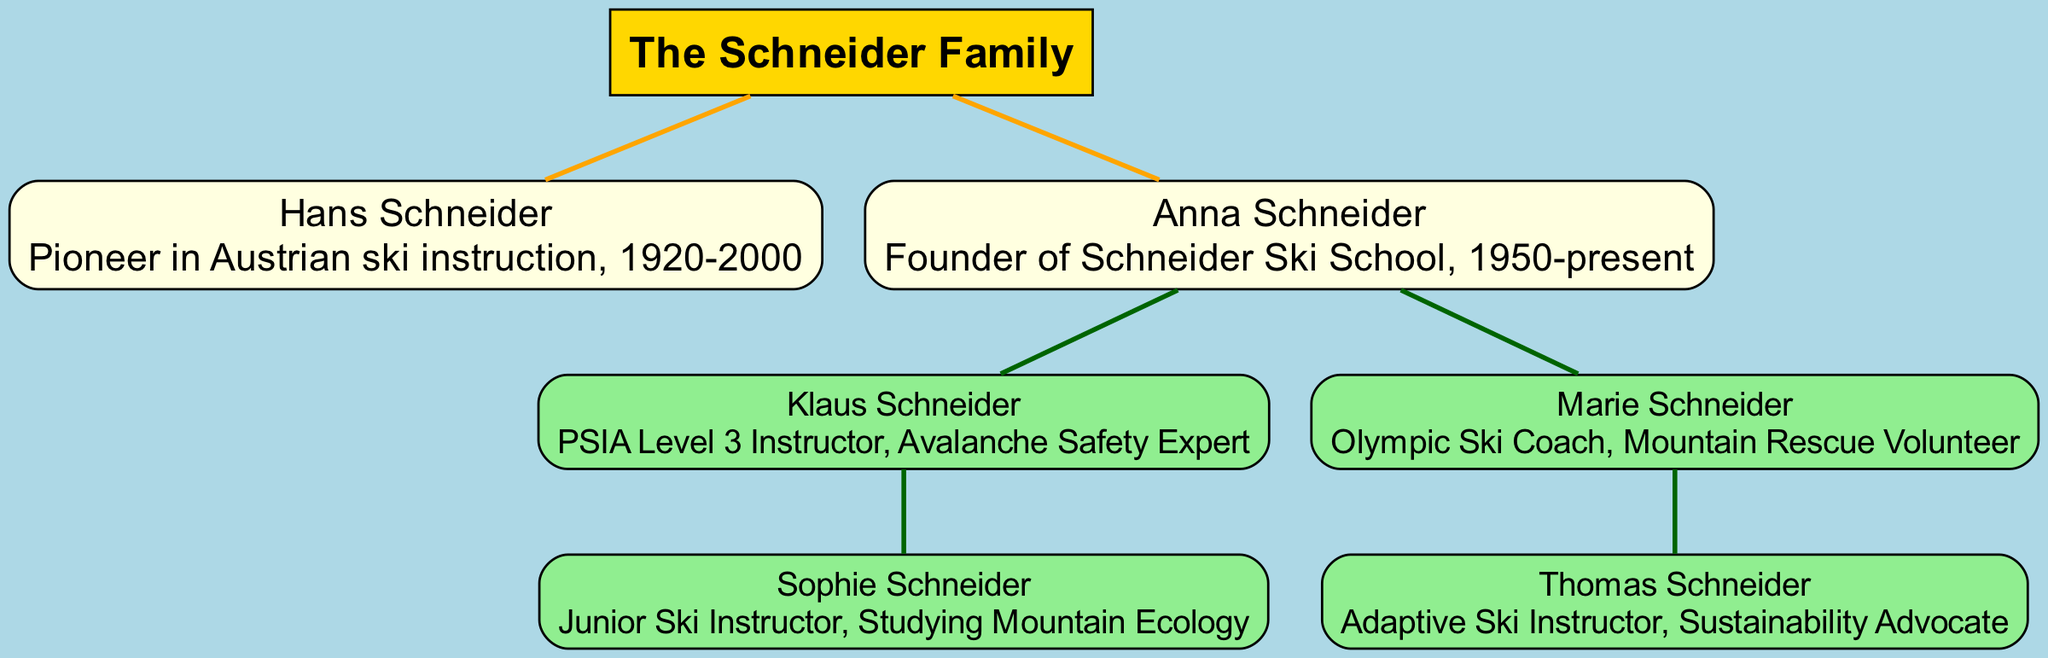What is the name of the root individual in the family tree? The root individual is clearly labeled at the top of the tree as "The Schneider Family." Thus, the answer is derived directly from the title provided.
Answer: The Schneider Family Who is the founder of the Schneider Ski School? The diagram identifies Anna Schneider as the founder of the Schneider Ski School. This information can be found directly stated in her section of the diagram.
Answer: Anna Schneider How many children does Anna Schneider have? The diagram shows two distinct children of Anna Schneider: Klaus Schneider and Marie Schneider. By counting the individual nodes branching from Anna, we can determine the number of children.
Answer: 2 What is Klaus Schneider's professional title? Klaus Schneider is labeled in the diagram as a "PSIA Level 3 Instructor" and "Avalanche Safety Expert." The answer is found within the text under his node.
Answer: PSIA Level 3 Instructor Which family member is involved in adaptive ski instruction? The diagram specifies that Thomas Schneider is the adaptive ski instructor. This can be inferred by looking at the children of Marie Schneider, where Thomas is mentioned.
Answer: Thomas Schneider What unique role does Marie Schneider hold besides coaching? The diagram identifies Marie Schneider as a mountain rescue volunteer in addition to being an Olympic ski coach. This is explicitly stated in her information.
Answer: Mountain Rescue Volunteer Who is studying mountain ecology? The diagram indicates that Sophie Schneider is studying mountain ecology. This information can be directly found in her description under Klaus Schneider.
Answer: Sophie Schneider How many generations are represented in the family tree? Looking up the structure, it becomes clear that there are two generations: the Schneider parents and their children, which encompasses all individuals displayed in the tree.
Answer: 2 In what year did Hans Schneider pass away? The diagram states that Hans Schneider lived from 1920 to 2000, indicating that he passed away in the year 2000. This information is directly provided in his node.
Answer: 2000 